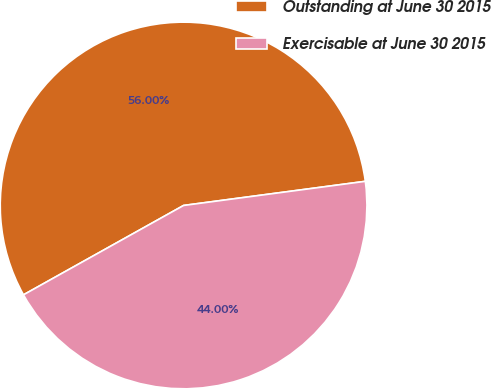Convert chart to OTSL. <chart><loc_0><loc_0><loc_500><loc_500><pie_chart><fcel>Outstanding at June 30 2015<fcel>Exercisable at June 30 2015<nl><fcel>56.0%<fcel>44.0%<nl></chart> 